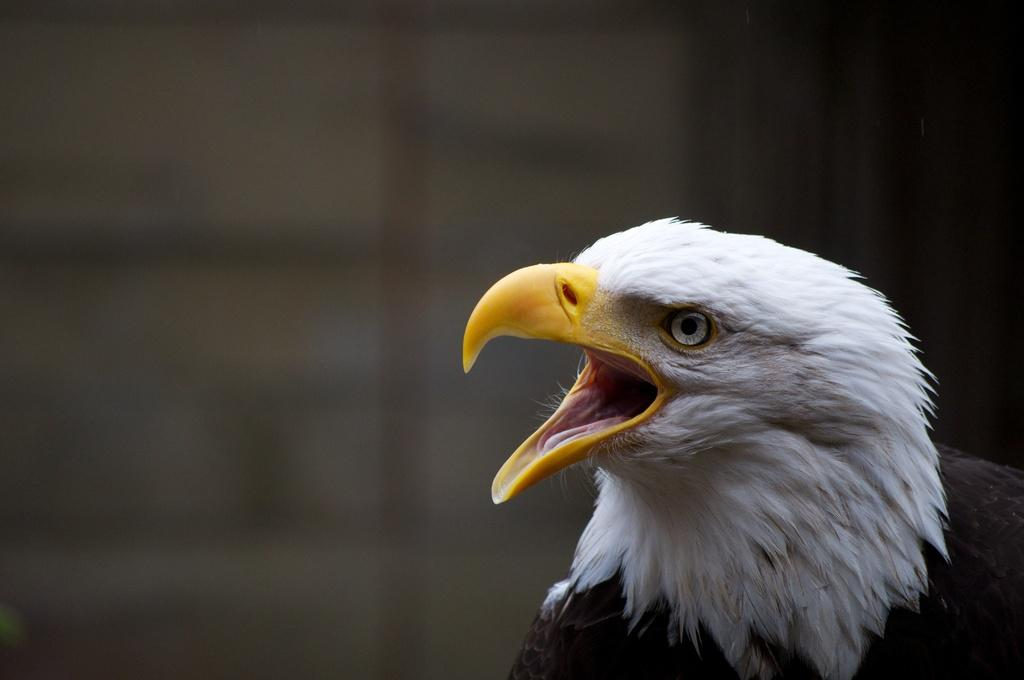What animal is the main subject of the image? There is an eagle in the image. Can you describe the quality of the image's background? The image is blurry in the background. What hobbies does the eagle enjoy in the image? There is no information about the eagle's hobbies in the image. How many ducks are swimming with the eagle in the image? There are no ducks present in the image; it features an eagle. 